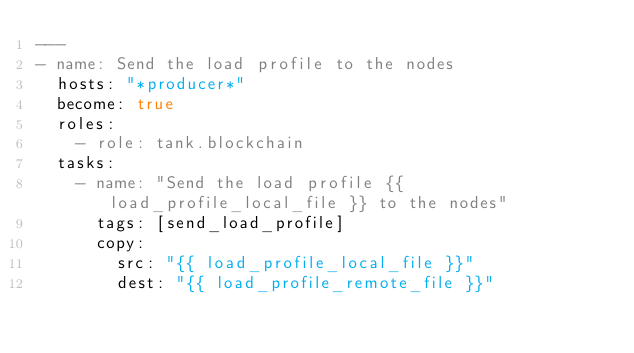Convert code to text. <code><loc_0><loc_0><loc_500><loc_500><_YAML_>---
- name: Send the load profile to the nodes
  hosts: "*producer*"
  become: true
  roles:
    - role: tank.blockchain
  tasks:
    - name: "Send the load profile {{ load_profile_local_file }} to the nodes"
      tags: [send_load_profile]
      copy:
        src: "{{ load_profile_local_file }}"
        dest: "{{ load_profile_remote_file }}"
</code> 